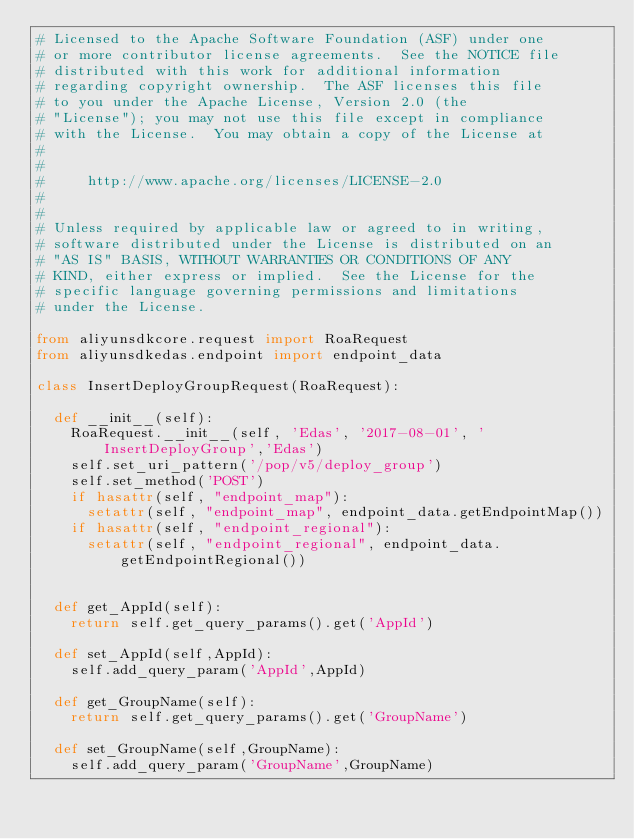<code> <loc_0><loc_0><loc_500><loc_500><_Python_># Licensed to the Apache Software Foundation (ASF) under one
# or more contributor license agreements.  See the NOTICE file
# distributed with this work for additional information
# regarding copyright ownership.  The ASF licenses this file
# to you under the Apache License, Version 2.0 (the
# "License"); you may not use this file except in compliance
# with the License.  You may obtain a copy of the License at
#
#
#     http://www.apache.org/licenses/LICENSE-2.0
#
#
# Unless required by applicable law or agreed to in writing,
# software distributed under the License is distributed on an
# "AS IS" BASIS, WITHOUT WARRANTIES OR CONDITIONS OF ANY
# KIND, either express or implied.  See the License for the
# specific language governing permissions and limitations
# under the License.

from aliyunsdkcore.request import RoaRequest
from aliyunsdkedas.endpoint import endpoint_data

class InsertDeployGroupRequest(RoaRequest):

	def __init__(self):
		RoaRequest.__init__(self, 'Edas', '2017-08-01', 'InsertDeployGroup','Edas')
		self.set_uri_pattern('/pop/v5/deploy_group')
		self.set_method('POST')
		if hasattr(self, "endpoint_map"):
			setattr(self, "endpoint_map", endpoint_data.getEndpointMap())
		if hasattr(self, "endpoint_regional"):
			setattr(self, "endpoint_regional", endpoint_data.getEndpointRegional())


	def get_AppId(self):
		return self.get_query_params().get('AppId')

	def set_AppId(self,AppId):
		self.add_query_param('AppId',AppId)

	def get_GroupName(self):
		return self.get_query_params().get('GroupName')

	def set_GroupName(self,GroupName):
		self.add_query_param('GroupName',GroupName)</code> 